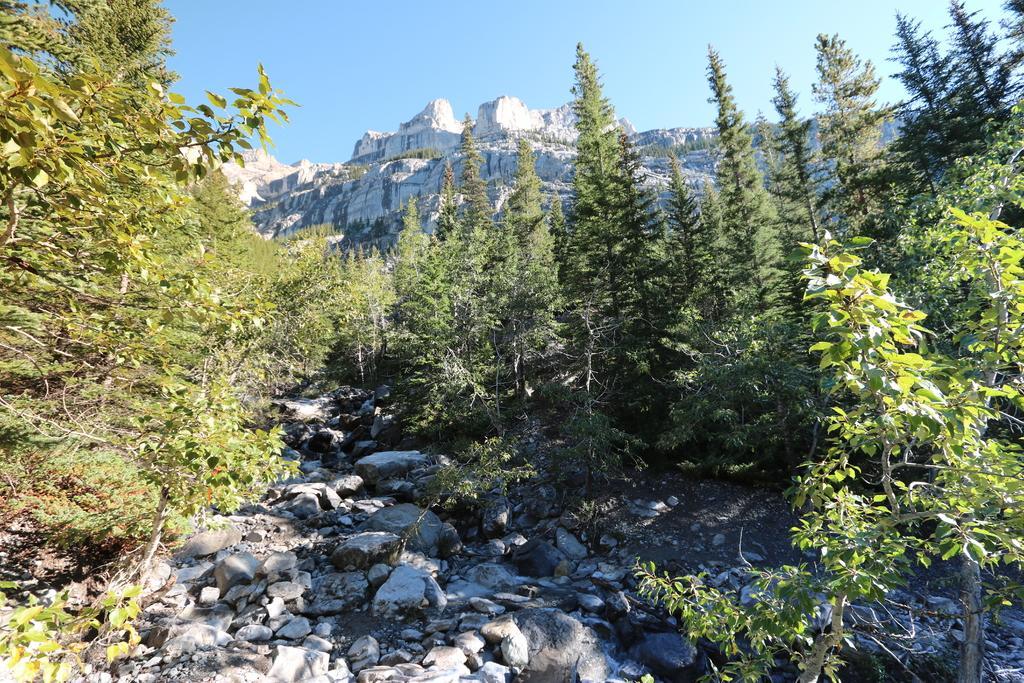Could you give a brief overview of what you see in this image? In the picture I can see so many trees, rocks and hills. 